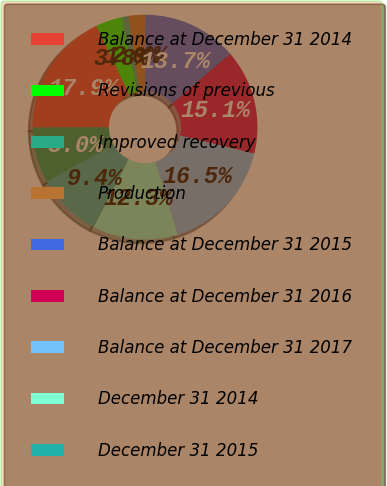Convert chart. <chart><loc_0><loc_0><loc_500><loc_500><pie_chart><fcel>Balance at December 31 2014<fcel>Revisions of previous<fcel>Improved recovery<fcel>Production<fcel>Balance at December 31 2015<fcel>Balance at December 31 2016<fcel>Balance at December 31 2017<fcel>December 31 2014<fcel>December 31 2015<fcel>December 31 2016<nl><fcel>17.93%<fcel>3.81%<fcel>0.96%<fcel>2.38%<fcel>13.67%<fcel>15.09%<fcel>16.51%<fcel>12.25%<fcel>9.41%<fcel>7.98%<nl></chart> 